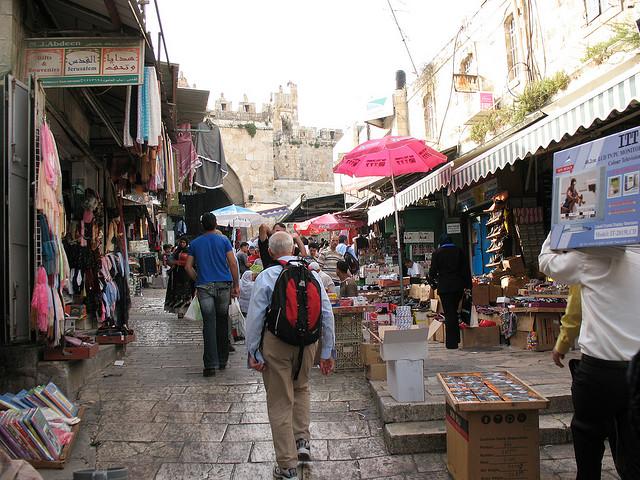What does the man have in his back pocket?
Give a very brief answer. Wallet. How many steps are there on the right?
Quick response, please. 2. How many umbrellas are visible?
Be succinct. 1. Is this in America?
Short answer required. No. How many people are here?
Keep it brief. 6. What color is the closest umbrella?
Answer briefly. Pink. 